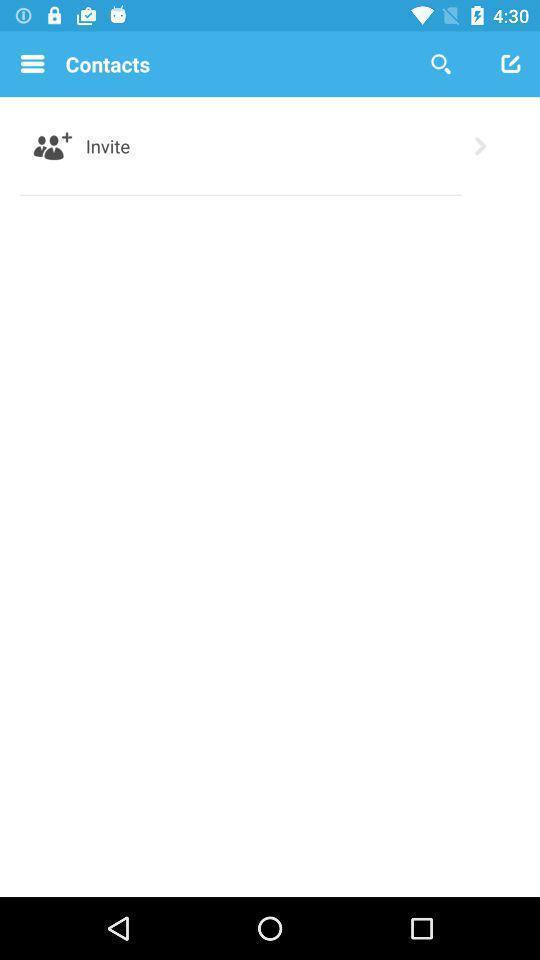Explain what's happening in this screen capture. Screen showing contacts page of a social app. 